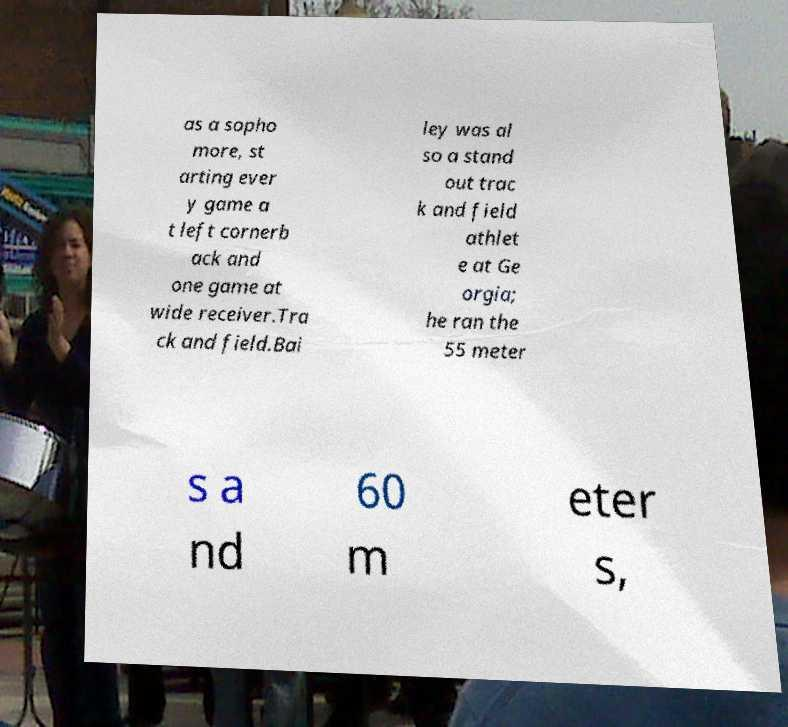Could you extract and type out the text from this image? as a sopho more, st arting ever y game a t left cornerb ack and one game at wide receiver.Tra ck and field.Bai ley was al so a stand out trac k and field athlet e at Ge orgia; he ran the 55 meter s a nd 60 m eter s, 